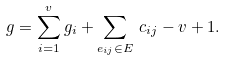<formula> <loc_0><loc_0><loc_500><loc_500>g & = \sum _ { i = 1 } ^ { v } g _ { i } + \sum _ { e _ { i j } \in E } \, c _ { i j } - v + 1 .</formula> 